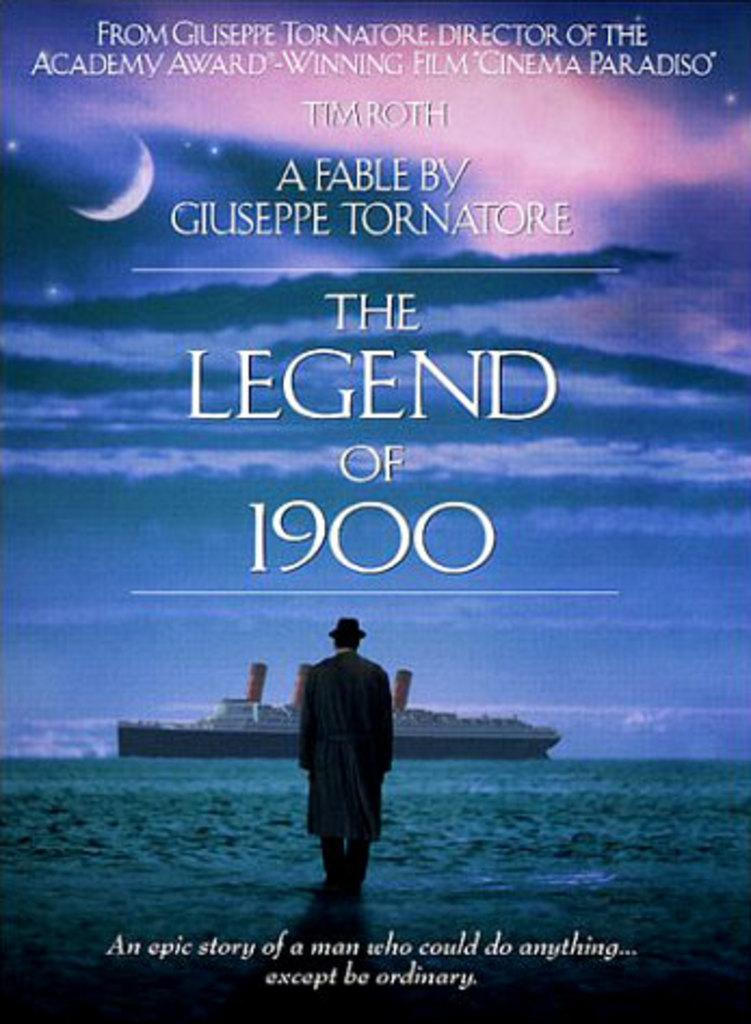<image>
Give a short and clear explanation of the subsequent image. A film by Giuseppe Tornatore called The Legend of 1900 